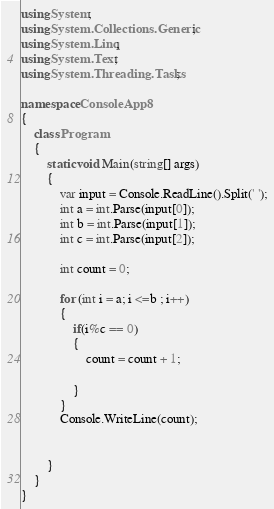<code> <loc_0><loc_0><loc_500><loc_500><_C#_>using System;
using System.Collections.Generic;
using System.Linq;
using System.Text;
using System.Threading.Tasks;

namespace ConsoleApp8
{
    class Program
    {
        static void Main(string[] args)
        {
            var input = Console.ReadLine().Split(' ');
            int a = int.Parse(input[0]);
            int b = int.Parse(input[1]);
            int c = int.Parse(input[2]);

            int count = 0;

            for (int i = a; i <=b ; i++)
            {
                if(i%c == 0)
                {
                    count = count + 1;

                }
            }
            Console.WriteLine(count);


        }
    }
}</code> 